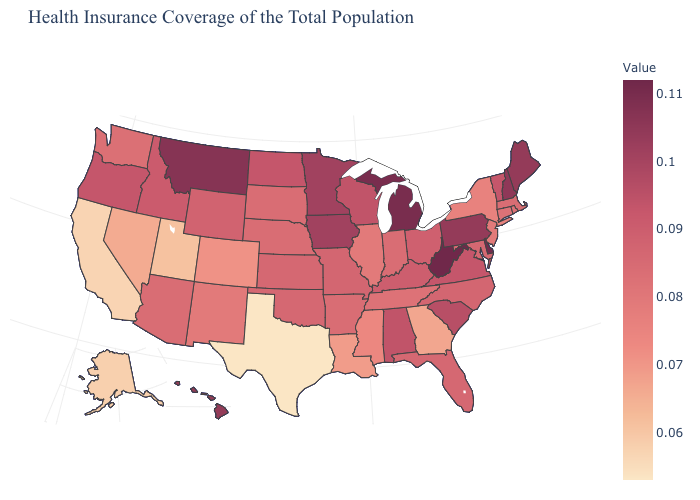Is the legend a continuous bar?
Be succinct. Yes. Which states have the lowest value in the USA?
Answer briefly. Texas. Is the legend a continuous bar?
Short answer required. Yes. Does Nebraska have a lower value than Alaska?
Be succinct. No. Is the legend a continuous bar?
Keep it brief. Yes. 